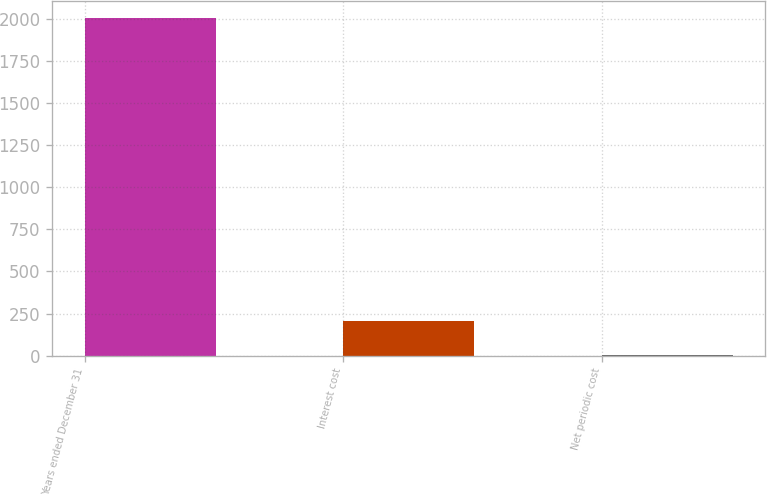Convert chart. <chart><loc_0><loc_0><loc_500><loc_500><bar_chart><fcel>Years ended December 31<fcel>Interest cost<fcel>Net periodic cost<nl><fcel>2008<fcel>204.22<fcel>3.8<nl></chart> 